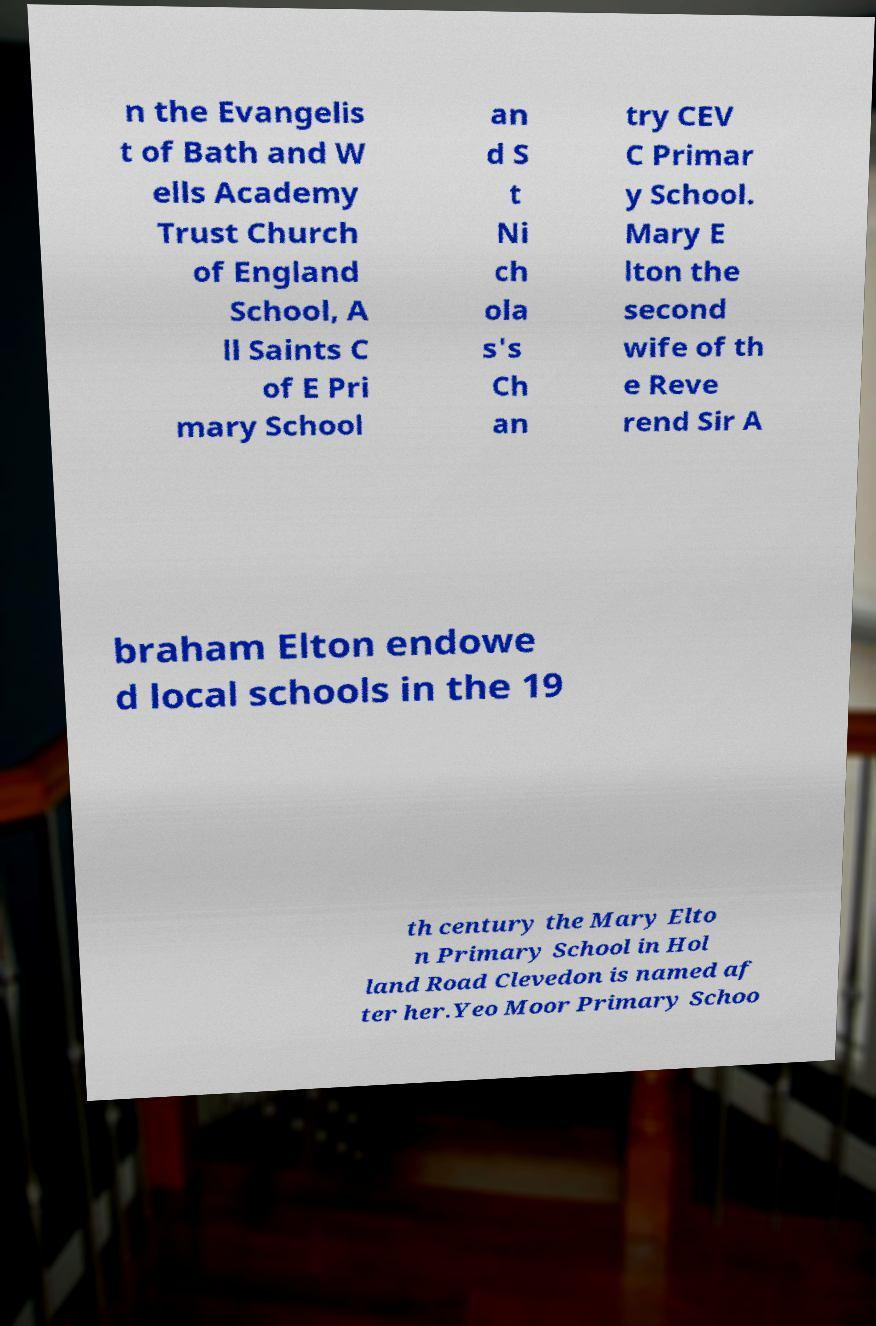There's text embedded in this image that I need extracted. Can you transcribe it verbatim? n the Evangelis t of Bath and W ells Academy Trust Church of England School, A ll Saints C of E Pri mary School an d S t Ni ch ola s's Ch an try CEV C Primar y School. Mary E lton the second wife of th e Reve rend Sir A braham Elton endowe d local schools in the 19 th century the Mary Elto n Primary School in Hol land Road Clevedon is named af ter her.Yeo Moor Primary Schoo 